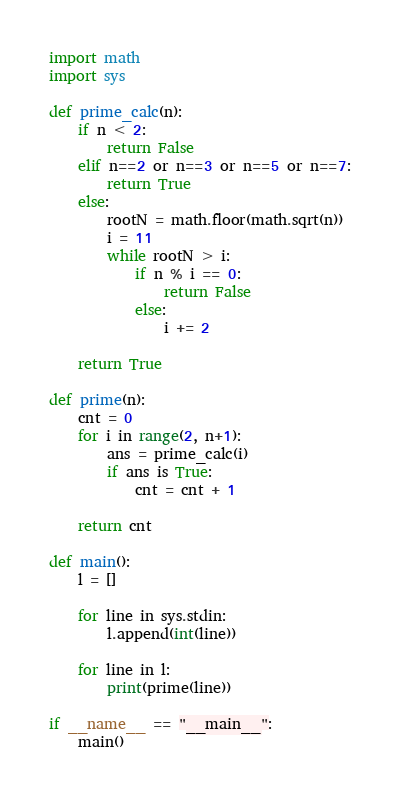Convert code to text. <code><loc_0><loc_0><loc_500><loc_500><_Python_>import math
import sys

def prime_calc(n):
    if n < 2:
        return False
    elif n==2 or n==3 or n==5 or n==7:
        return True
    else:
        rootN = math.floor(math.sqrt(n))
        i = 11
        while rootN > i:
            if n % i == 0:
                return False
            else:
                i += 2

    return True

def prime(n):
    cnt = 0
    for i in range(2, n+1):
        ans = prime_calc(i)
        if ans is True:
            cnt = cnt + 1

    return cnt

def main():
    l = []

    for line in sys.stdin:
        l.append(int(line))

    for line in l:
        print(prime(line))

if __name__ == "__main__":
    main()
</code> 